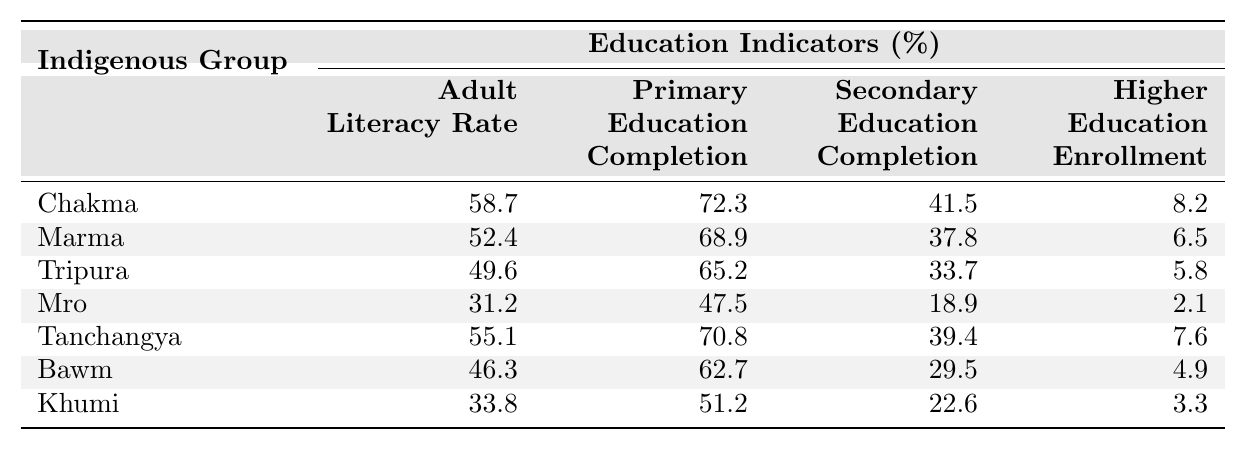What is the adult literacy rate of the Chakma group? The table shows that the adult literacy rate for the Chakma group is explicitly listed as 58.7%.
Answer: 58.7% Which indigenous group has the highest completion rate for primary education? Looking at the table, the Chakma group has the highest primary education completion rate at 72.3%.
Answer: Chakma What is the difference between the adult literacy rates of the Chakma and Marma groups? The adult literacy rate for Chakma is 58.7% and for Marma is 52.4%. The difference is calculated as 58.7 - 52.4 = 6.3%.
Answer: 6.3% Which group has a higher percentage of secondary education completion: Tanchangya or Bawm? Tanchangya has a secondary education completion rate of 39.4% and Bawm has 29.5%. Therefore, Tanchangya has a higher percentage.
Answer: Tanchangya Is the higher education enrollment rate of the Tripura group greater than 5%? The higher education enrollment rate for Tripura is 5.8%, which is greater than 5%. Thus, the answer is yes.
Answer: Yes What is the average adult literacy rate among all the groups? The adult literacy rates are 58.7, 52.4, 49.6, 31.2, 55.1, 46.3, and 33.8, giving a total of 327.1. With 7 groups, the average is 327.1 / 7 ≈ 46.7%.
Answer: 46.7% Which indigenous group has the lowest higher education enrollment? The group with the lowest higher education enrollment rate is Mro at 2.1%.
Answer: Mro If we combine the primary education completion rates for the Chakma and Tanchangya groups, what is the total? The primary education completion rates are 72.3% for Chakma and 70.8% for Tanchangya. Adding these gives 72.3 + 70.8 = 143.1%.
Answer: 143.1% Is the adult literacy rate of Khumi greater than the average adult literacy rate across all groups? The average adult literacy rate is approximately 46.7%, while Khumi's rate is 33.8%, which is less than the average.
Answer: No Which group completed secondary education at a rate less than 20%? The group Mro has a secondary education completion rate of 18.9%, which is less than 20%.
Answer: Mro 